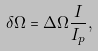Convert formula to latex. <formula><loc_0><loc_0><loc_500><loc_500>\delta \Omega = \Delta \Omega \frac { I } { I _ { p } } ,</formula> 